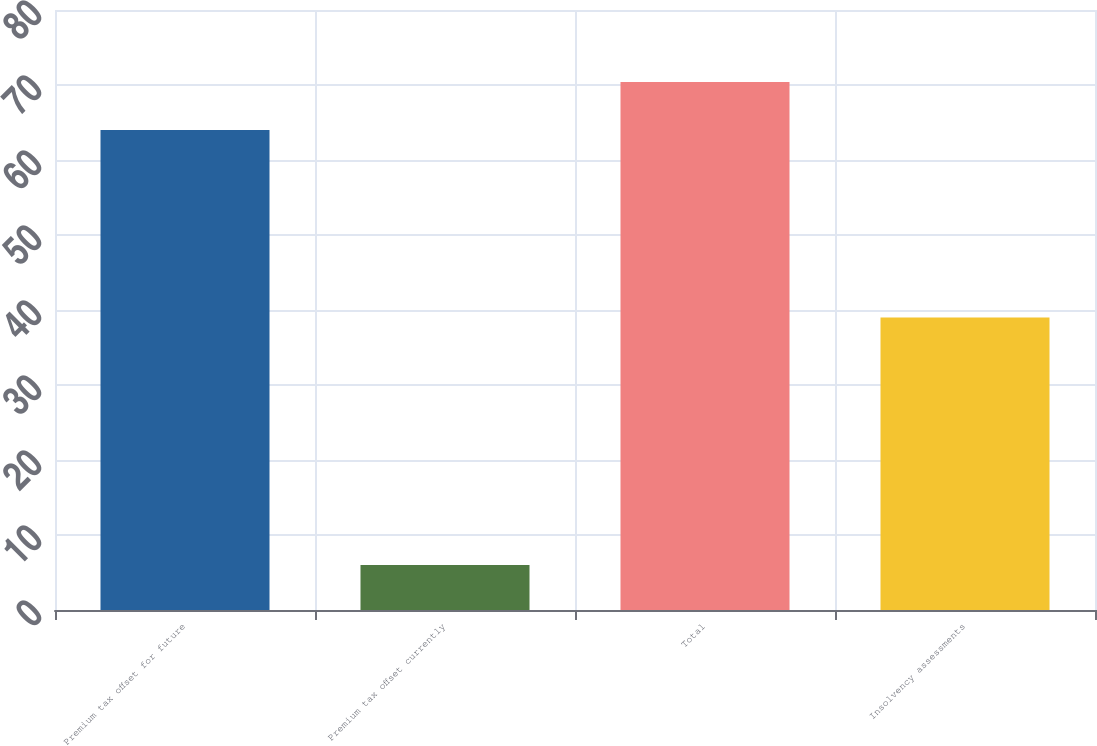Convert chart. <chart><loc_0><loc_0><loc_500><loc_500><bar_chart><fcel>Premium tax offset for future<fcel>Premium tax offset currently<fcel>Total<fcel>Insolvency assessments<nl><fcel>64<fcel>6<fcel>70.4<fcel>39<nl></chart> 